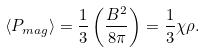<formula> <loc_0><loc_0><loc_500><loc_500>\langle P _ { m a g } \rangle = \frac { 1 } { 3 } \left ( \frac { B ^ { 2 } } { 8 \pi } \right ) = \frac { 1 } { 3 } \chi \rho .</formula> 